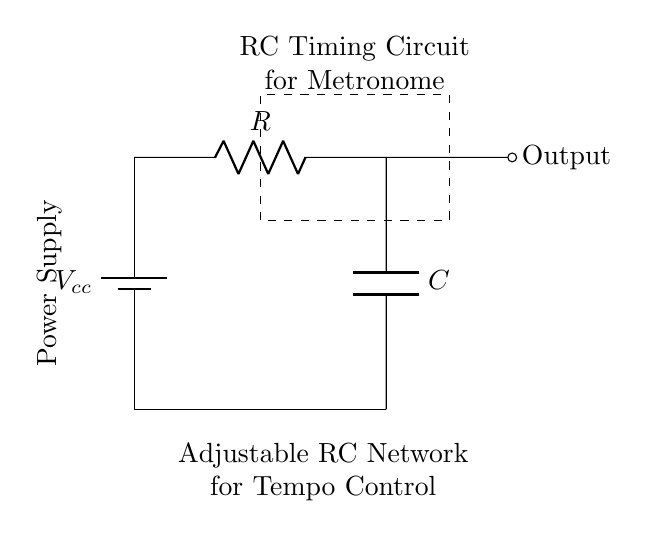What type of circuit is shown here? This circuit is an RC timing circuit, which specifically utilizes a resistor and a capacitor to control timing. The label in the diagram directly states "RC Timing Circuit for Metronome."
Answer: RC timing circuit What components are present in this circuit? The diagram contains a battery, a resistor, and a capacitor, which are all labeled appropriately. The battery is labeled as Vcc, the resistor as R, and the capacitor as C.
Answer: Battery, Resistor, Capacitor What is the role of the adjustable RC network in this circuit? The adjustable RC network's purpose is to allow users to modify the resistance and capacitance values, thus controlling the tempo of the metronome. The diagram explicitly states this function below the circuit.
Answer: Tempo Control What does the output node indicate? The output node represents where the timing signal is taken from the circuit for further use in the metronome function. The node is marked clearly on the right side of the circuit with the label "Output."
Answer: Timing signal If the resistance is increased, what effect will it have on the timing interval? Increasing resistance in an RC circuit will increase the timing interval for the metronome because the time constant τ (tau) is calculated as τ = R C, and a larger R leads to a larger τ, prolonging the time taken to charge or discharge the capacitor.
Answer: Increase timing interval What does a capacitor do in this RC timing circuit? The capacitor stores and releases electrical energy, affecting the timing characteristics of the circuit. As the circuit charges and discharges through the resistor, the capacitor's ability to store energy dictates how long the metronome signal lasts.
Answer: Store and release energy 